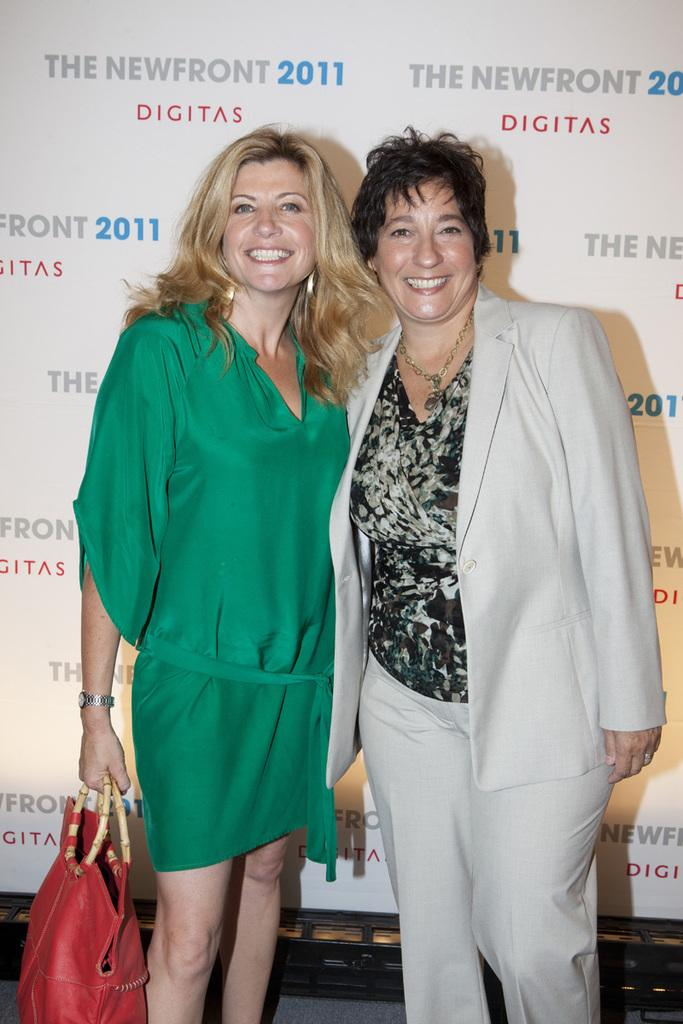How many people are in the image? There are two women in the image. What is the facial expression of the women? Both women are smiling. What object is one of the women holding? One woman is holding a handbag. What can be seen in the background of the image? There is a hoarding visible in the background. Can you tell me how many eggs are on the ground in the image? There are no eggs present in the image. What type of creature is touching the handbag in the image? There is no creature touching the handbag in the image. 